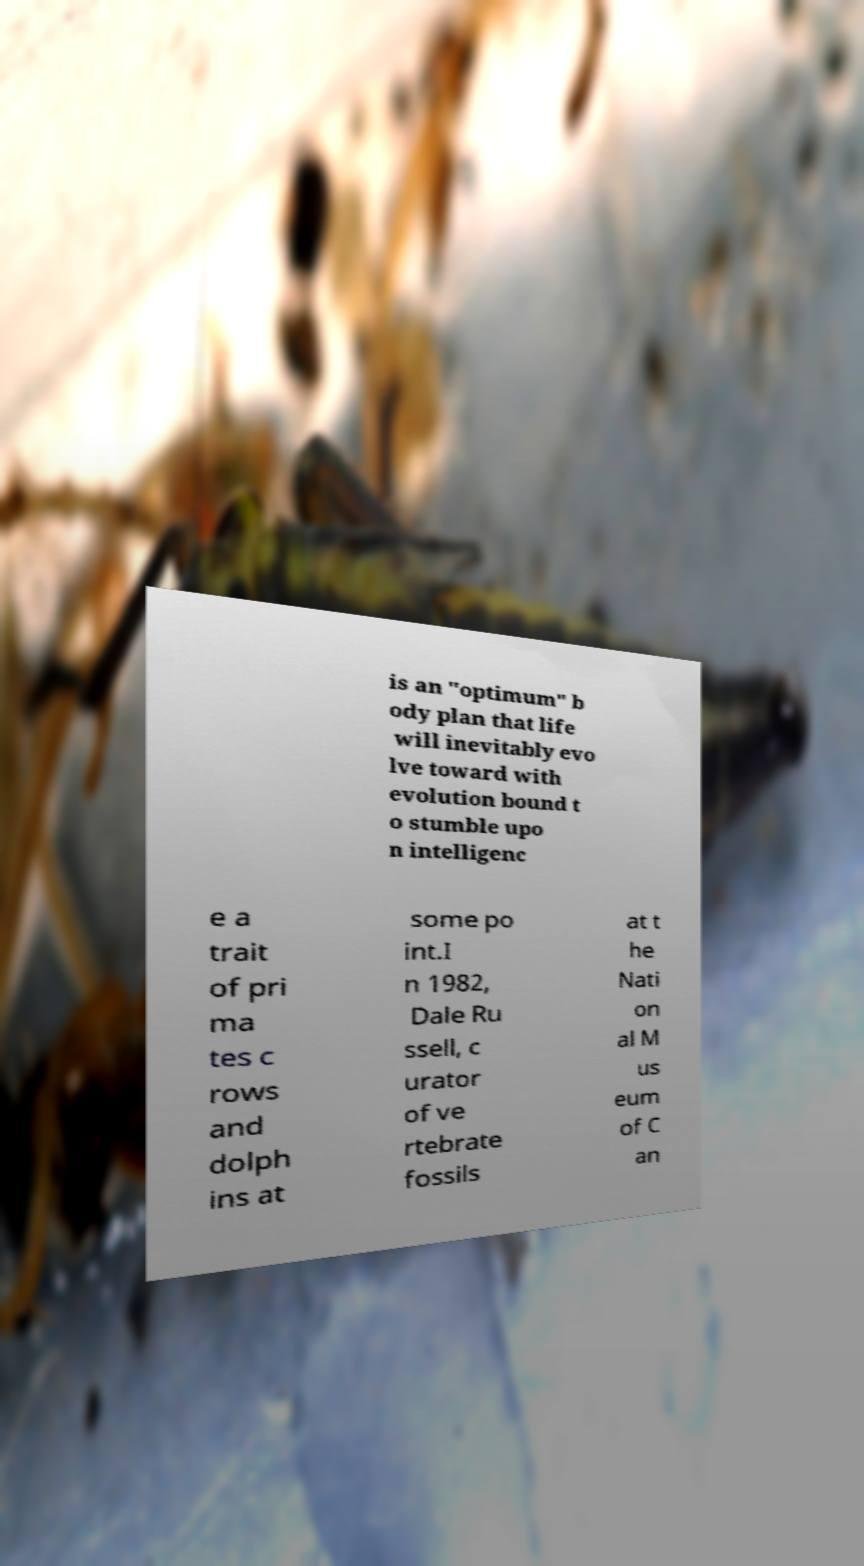What messages or text are displayed in this image? I need them in a readable, typed format. is an "optimum" b ody plan that life will inevitably evo lve toward with evolution bound t o stumble upo n intelligenc e a trait of pri ma tes c rows and dolph ins at some po int.I n 1982, Dale Ru ssell, c urator of ve rtebrate fossils at t he Nati on al M us eum of C an 